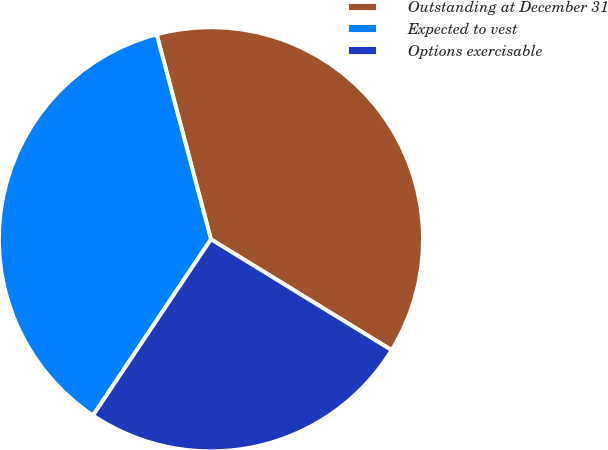Convert chart. <chart><loc_0><loc_0><loc_500><loc_500><pie_chart><fcel>Outstanding at December 31<fcel>Expected to vest<fcel>Options exercisable<nl><fcel>37.88%<fcel>36.49%<fcel>25.63%<nl></chart> 